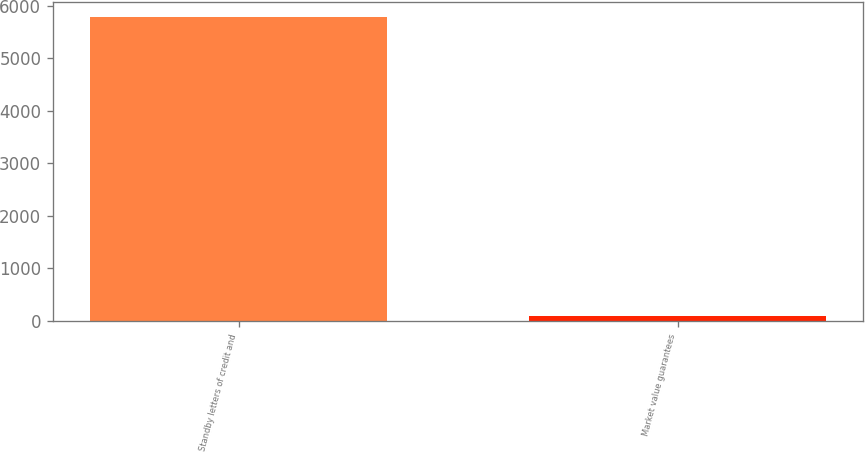<chart> <loc_0><loc_0><loc_500><loc_500><bar_chart><fcel>Standby letters of credit and<fcel>Market value guarantees<nl><fcel>5792<fcel>104<nl></chart> 